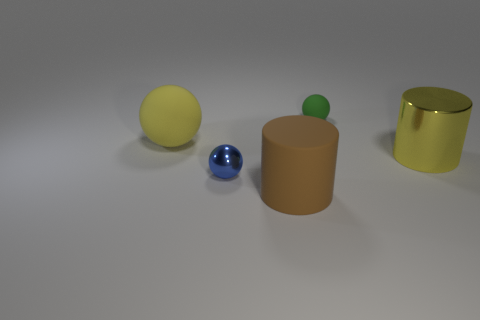Is the color of the large metal object the same as the big rubber sphere?
Offer a terse response. Yes. Is there a yellow thing that has the same material as the tiny green sphere?
Provide a short and direct response. Yes. Is the yellow cylinder made of the same material as the yellow sphere?
Give a very brief answer. No. There is another shiny thing that is the same size as the brown object; what is its color?
Keep it short and to the point. Yellow. How many other things are there of the same shape as the blue metal object?
Keep it short and to the point. 2. There is a brown thing; is its size the same as the yellow rubber object behind the shiny ball?
Offer a terse response. Yes. What number of objects are large gray metallic things or brown cylinders?
Offer a very short reply. 1. What number of other objects are there of the same size as the yellow rubber ball?
Provide a short and direct response. 2. Do the big shiny cylinder and the matte ball to the left of the brown rubber cylinder have the same color?
Ensure brevity in your answer.  Yes. How many balls are either tiny blue things or green things?
Offer a terse response. 2. 